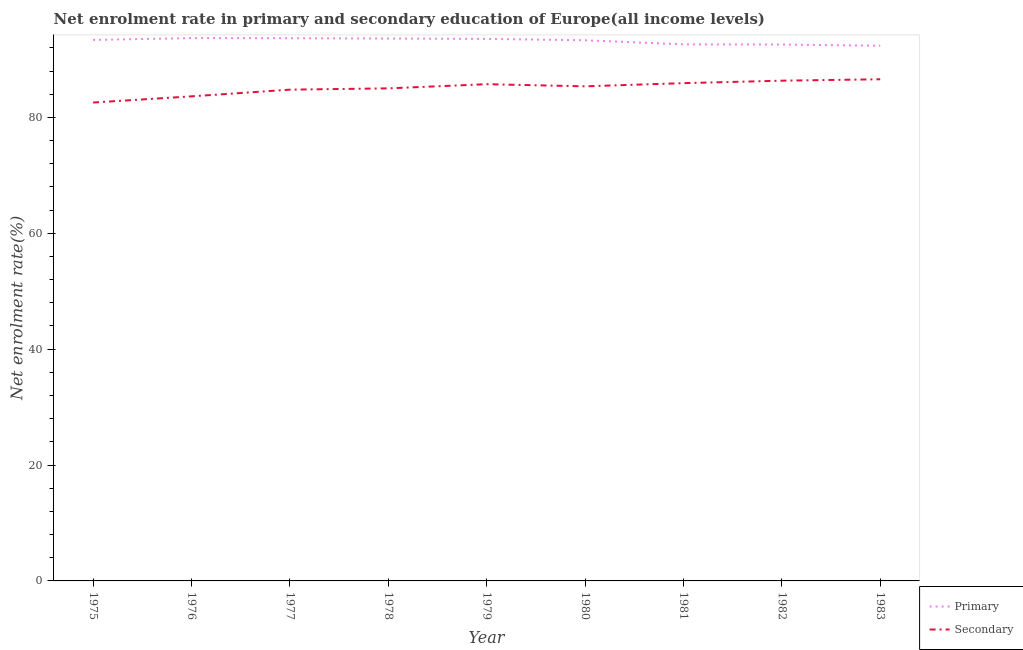Does the line corresponding to enrollment rate in primary education intersect with the line corresponding to enrollment rate in secondary education?
Keep it short and to the point. No. What is the enrollment rate in secondary education in 1980?
Your response must be concise. 85.36. Across all years, what is the maximum enrollment rate in primary education?
Make the answer very short. 93.68. Across all years, what is the minimum enrollment rate in primary education?
Offer a terse response. 92.36. In which year was the enrollment rate in primary education maximum?
Keep it short and to the point. 1976. What is the total enrollment rate in primary education in the graph?
Your response must be concise. 838.69. What is the difference between the enrollment rate in secondary education in 1976 and that in 1982?
Provide a short and direct response. -2.7. What is the difference between the enrollment rate in secondary education in 1976 and the enrollment rate in primary education in 1975?
Make the answer very short. -9.74. What is the average enrollment rate in primary education per year?
Keep it short and to the point. 93.19. In the year 1978, what is the difference between the enrollment rate in secondary education and enrollment rate in primary education?
Make the answer very short. -8.6. In how many years, is the enrollment rate in secondary education greater than 12 %?
Keep it short and to the point. 9. What is the ratio of the enrollment rate in primary education in 1975 to that in 1976?
Give a very brief answer. 1. What is the difference between the highest and the second highest enrollment rate in secondary education?
Provide a short and direct response. 0.25. What is the difference between the highest and the lowest enrollment rate in primary education?
Make the answer very short. 1.32. Is the sum of the enrollment rate in secondary education in 1976 and 1977 greater than the maximum enrollment rate in primary education across all years?
Make the answer very short. Yes. Is the enrollment rate in primary education strictly greater than the enrollment rate in secondary education over the years?
Your answer should be compact. Yes. What is the difference between two consecutive major ticks on the Y-axis?
Provide a succinct answer. 20. Are the values on the major ticks of Y-axis written in scientific E-notation?
Give a very brief answer. No. Does the graph contain any zero values?
Provide a succinct answer. No. How many legend labels are there?
Provide a short and direct response. 2. How are the legend labels stacked?
Offer a very short reply. Vertical. What is the title of the graph?
Provide a succinct answer. Net enrolment rate in primary and secondary education of Europe(all income levels). Does "Highest 10% of population" appear as one of the legend labels in the graph?
Ensure brevity in your answer.  No. What is the label or title of the X-axis?
Your response must be concise. Year. What is the label or title of the Y-axis?
Give a very brief answer. Net enrolment rate(%). What is the Net enrolment rate(%) in Primary in 1975?
Keep it short and to the point. 93.37. What is the Net enrolment rate(%) of Secondary in 1975?
Your answer should be very brief. 82.56. What is the Net enrolment rate(%) of Primary in 1976?
Your answer should be compact. 93.68. What is the Net enrolment rate(%) of Secondary in 1976?
Make the answer very short. 83.63. What is the Net enrolment rate(%) in Primary in 1977?
Your answer should be compact. 93.66. What is the Net enrolment rate(%) in Secondary in 1977?
Make the answer very short. 84.78. What is the Net enrolment rate(%) of Primary in 1978?
Provide a succinct answer. 93.61. What is the Net enrolment rate(%) in Secondary in 1978?
Offer a very short reply. 85.01. What is the Net enrolment rate(%) of Primary in 1979?
Your answer should be very brief. 93.54. What is the Net enrolment rate(%) in Secondary in 1979?
Offer a very short reply. 85.72. What is the Net enrolment rate(%) of Primary in 1980?
Provide a succinct answer. 93.31. What is the Net enrolment rate(%) in Secondary in 1980?
Provide a succinct answer. 85.36. What is the Net enrolment rate(%) of Primary in 1981?
Give a very brief answer. 92.6. What is the Net enrolment rate(%) of Secondary in 1981?
Your answer should be compact. 85.91. What is the Net enrolment rate(%) of Primary in 1982?
Your answer should be compact. 92.57. What is the Net enrolment rate(%) of Secondary in 1982?
Provide a succinct answer. 86.33. What is the Net enrolment rate(%) in Primary in 1983?
Offer a very short reply. 92.36. What is the Net enrolment rate(%) of Secondary in 1983?
Your answer should be compact. 86.58. Across all years, what is the maximum Net enrolment rate(%) of Primary?
Ensure brevity in your answer.  93.68. Across all years, what is the maximum Net enrolment rate(%) in Secondary?
Keep it short and to the point. 86.58. Across all years, what is the minimum Net enrolment rate(%) in Primary?
Keep it short and to the point. 92.36. Across all years, what is the minimum Net enrolment rate(%) of Secondary?
Make the answer very short. 82.56. What is the total Net enrolment rate(%) of Primary in the graph?
Offer a very short reply. 838.69. What is the total Net enrolment rate(%) of Secondary in the graph?
Your response must be concise. 765.88. What is the difference between the Net enrolment rate(%) in Primary in 1975 and that in 1976?
Provide a succinct answer. -0.32. What is the difference between the Net enrolment rate(%) in Secondary in 1975 and that in 1976?
Provide a short and direct response. -1.07. What is the difference between the Net enrolment rate(%) of Primary in 1975 and that in 1977?
Provide a short and direct response. -0.29. What is the difference between the Net enrolment rate(%) in Secondary in 1975 and that in 1977?
Keep it short and to the point. -2.22. What is the difference between the Net enrolment rate(%) in Primary in 1975 and that in 1978?
Give a very brief answer. -0.25. What is the difference between the Net enrolment rate(%) in Secondary in 1975 and that in 1978?
Give a very brief answer. -2.45. What is the difference between the Net enrolment rate(%) in Primary in 1975 and that in 1979?
Your response must be concise. -0.17. What is the difference between the Net enrolment rate(%) in Secondary in 1975 and that in 1979?
Provide a short and direct response. -3.16. What is the difference between the Net enrolment rate(%) in Primary in 1975 and that in 1980?
Provide a short and direct response. 0.06. What is the difference between the Net enrolment rate(%) in Secondary in 1975 and that in 1980?
Provide a short and direct response. -2.8. What is the difference between the Net enrolment rate(%) of Primary in 1975 and that in 1981?
Make the answer very short. 0.77. What is the difference between the Net enrolment rate(%) in Secondary in 1975 and that in 1981?
Provide a short and direct response. -3.35. What is the difference between the Net enrolment rate(%) of Primary in 1975 and that in 1982?
Give a very brief answer. 0.8. What is the difference between the Net enrolment rate(%) of Secondary in 1975 and that in 1982?
Give a very brief answer. -3.77. What is the difference between the Net enrolment rate(%) in Primary in 1975 and that in 1983?
Your response must be concise. 1. What is the difference between the Net enrolment rate(%) in Secondary in 1975 and that in 1983?
Give a very brief answer. -4.02. What is the difference between the Net enrolment rate(%) in Primary in 1976 and that in 1977?
Give a very brief answer. 0.02. What is the difference between the Net enrolment rate(%) of Secondary in 1976 and that in 1977?
Give a very brief answer. -1.15. What is the difference between the Net enrolment rate(%) of Primary in 1976 and that in 1978?
Your answer should be very brief. 0.07. What is the difference between the Net enrolment rate(%) of Secondary in 1976 and that in 1978?
Keep it short and to the point. -1.38. What is the difference between the Net enrolment rate(%) in Primary in 1976 and that in 1979?
Provide a succinct answer. 0.14. What is the difference between the Net enrolment rate(%) of Secondary in 1976 and that in 1979?
Offer a terse response. -2.1. What is the difference between the Net enrolment rate(%) of Primary in 1976 and that in 1980?
Give a very brief answer. 0.37. What is the difference between the Net enrolment rate(%) in Secondary in 1976 and that in 1980?
Provide a succinct answer. -1.73. What is the difference between the Net enrolment rate(%) of Primary in 1976 and that in 1981?
Provide a short and direct response. 1.08. What is the difference between the Net enrolment rate(%) in Secondary in 1976 and that in 1981?
Provide a succinct answer. -2.28. What is the difference between the Net enrolment rate(%) of Primary in 1976 and that in 1982?
Keep it short and to the point. 1.11. What is the difference between the Net enrolment rate(%) of Secondary in 1976 and that in 1982?
Ensure brevity in your answer.  -2.7. What is the difference between the Net enrolment rate(%) in Primary in 1976 and that in 1983?
Offer a very short reply. 1.32. What is the difference between the Net enrolment rate(%) in Secondary in 1976 and that in 1983?
Your answer should be compact. -2.95. What is the difference between the Net enrolment rate(%) of Primary in 1977 and that in 1978?
Offer a terse response. 0.04. What is the difference between the Net enrolment rate(%) in Secondary in 1977 and that in 1978?
Offer a terse response. -0.22. What is the difference between the Net enrolment rate(%) of Primary in 1977 and that in 1979?
Keep it short and to the point. 0.12. What is the difference between the Net enrolment rate(%) of Secondary in 1977 and that in 1979?
Offer a terse response. -0.94. What is the difference between the Net enrolment rate(%) of Primary in 1977 and that in 1980?
Keep it short and to the point. 0.35. What is the difference between the Net enrolment rate(%) of Secondary in 1977 and that in 1980?
Ensure brevity in your answer.  -0.57. What is the difference between the Net enrolment rate(%) in Primary in 1977 and that in 1981?
Provide a succinct answer. 1.06. What is the difference between the Net enrolment rate(%) in Secondary in 1977 and that in 1981?
Your answer should be very brief. -1.12. What is the difference between the Net enrolment rate(%) of Primary in 1977 and that in 1982?
Your answer should be very brief. 1.09. What is the difference between the Net enrolment rate(%) of Secondary in 1977 and that in 1982?
Provide a succinct answer. -1.55. What is the difference between the Net enrolment rate(%) in Primary in 1977 and that in 1983?
Provide a succinct answer. 1.3. What is the difference between the Net enrolment rate(%) in Secondary in 1977 and that in 1983?
Keep it short and to the point. -1.79. What is the difference between the Net enrolment rate(%) of Primary in 1978 and that in 1979?
Offer a terse response. 0.07. What is the difference between the Net enrolment rate(%) of Secondary in 1978 and that in 1979?
Ensure brevity in your answer.  -0.72. What is the difference between the Net enrolment rate(%) of Primary in 1978 and that in 1980?
Give a very brief answer. 0.3. What is the difference between the Net enrolment rate(%) of Secondary in 1978 and that in 1980?
Your answer should be compact. -0.35. What is the difference between the Net enrolment rate(%) of Primary in 1978 and that in 1981?
Offer a very short reply. 1.01. What is the difference between the Net enrolment rate(%) in Secondary in 1978 and that in 1981?
Provide a succinct answer. -0.9. What is the difference between the Net enrolment rate(%) of Primary in 1978 and that in 1982?
Offer a terse response. 1.04. What is the difference between the Net enrolment rate(%) in Secondary in 1978 and that in 1982?
Offer a very short reply. -1.32. What is the difference between the Net enrolment rate(%) of Primary in 1978 and that in 1983?
Your answer should be compact. 1.25. What is the difference between the Net enrolment rate(%) of Secondary in 1978 and that in 1983?
Offer a terse response. -1.57. What is the difference between the Net enrolment rate(%) in Primary in 1979 and that in 1980?
Your answer should be very brief. 0.23. What is the difference between the Net enrolment rate(%) in Secondary in 1979 and that in 1980?
Offer a very short reply. 0.37. What is the difference between the Net enrolment rate(%) of Primary in 1979 and that in 1981?
Offer a very short reply. 0.94. What is the difference between the Net enrolment rate(%) in Secondary in 1979 and that in 1981?
Give a very brief answer. -0.18. What is the difference between the Net enrolment rate(%) in Primary in 1979 and that in 1982?
Offer a terse response. 0.97. What is the difference between the Net enrolment rate(%) in Secondary in 1979 and that in 1982?
Offer a terse response. -0.61. What is the difference between the Net enrolment rate(%) of Primary in 1979 and that in 1983?
Make the answer very short. 1.18. What is the difference between the Net enrolment rate(%) in Secondary in 1979 and that in 1983?
Your answer should be very brief. -0.85. What is the difference between the Net enrolment rate(%) in Primary in 1980 and that in 1981?
Your answer should be compact. 0.71. What is the difference between the Net enrolment rate(%) of Secondary in 1980 and that in 1981?
Offer a very short reply. -0.55. What is the difference between the Net enrolment rate(%) in Primary in 1980 and that in 1982?
Provide a short and direct response. 0.74. What is the difference between the Net enrolment rate(%) of Secondary in 1980 and that in 1982?
Keep it short and to the point. -0.97. What is the difference between the Net enrolment rate(%) of Primary in 1980 and that in 1983?
Keep it short and to the point. 0.95. What is the difference between the Net enrolment rate(%) of Secondary in 1980 and that in 1983?
Give a very brief answer. -1.22. What is the difference between the Net enrolment rate(%) of Primary in 1981 and that in 1982?
Your answer should be very brief. 0.03. What is the difference between the Net enrolment rate(%) in Secondary in 1981 and that in 1982?
Your response must be concise. -0.43. What is the difference between the Net enrolment rate(%) in Primary in 1981 and that in 1983?
Offer a terse response. 0.24. What is the difference between the Net enrolment rate(%) in Secondary in 1981 and that in 1983?
Offer a very short reply. -0.67. What is the difference between the Net enrolment rate(%) in Primary in 1982 and that in 1983?
Provide a succinct answer. 0.21. What is the difference between the Net enrolment rate(%) in Secondary in 1982 and that in 1983?
Give a very brief answer. -0.25. What is the difference between the Net enrolment rate(%) of Primary in 1975 and the Net enrolment rate(%) of Secondary in 1976?
Ensure brevity in your answer.  9.74. What is the difference between the Net enrolment rate(%) of Primary in 1975 and the Net enrolment rate(%) of Secondary in 1977?
Offer a very short reply. 8.58. What is the difference between the Net enrolment rate(%) in Primary in 1975 and the Net enrolment rate(%) in Secondary in 1978?
Your answer should be compact. 8.36. What is the difference between the Net enrolment rate(%) in Primary in 1975 and the Net enrolment rate(%) in Secondary in 1979?
Keep it short and to the point. 7.64. What is the difference between the Net enrolment rate(%) of Primary in 1975 and the Net enrolment rate(%) of Secondary in 1980?
Your answer should be very brief. 8.01. What is the difference between the Net enrolment rate(%) in Primary in 1975 and the Net enrolment rate(%) in Secondary in 1981?
Your answer should be compact. 7.46. What is the difference between the Net enrolment rate(%) in Primary in 1975 and the Net enrolment rate(%) in Secondary in 1982?
Your answer should be very brief. 7.03. What is the difference between the Net enrolment rate(%) of Primary in 1975 and the Net enrolment rate(%) of Secondary in 1983?
Your answer should be very brief. 6.79. What is the difference between the Net enrolment rate(%) in Primary in 1976 and the Net enrolment rate(%) in Secondary in 1977?
Your response must be concise. 8.9. What is the difference between the Net enrolment rate(%) in Primary in 1976 and the Net enrolment rate(%) in Secondary in 1978?
Provide a short and direct response. 8.67. What is the difference between the Net enrolment rate(%) in Primary in 1976 and the Net enrolment rate(%) in Secondary in 1979?
Your answer should be compact. 7.96. What is the difference between the Net enrolment rate(%) of Primary in 1976 and the Net enrolment rate(%) of Secondary in 1980?
Provide a short and direct response. 8.32. What is the difference between the Net enrolment rate(%) in Primary in 1976 and the Net enrolment rate(%) in Secondary in 1981?
Offer a very short reply. 7.78. What is the difference between the Net enrolment rate(%) in Primary in 1976 and the Net enrolment rate(%) in Secondary in 1982?
Your response must be concise. 7.35. What is the difference between the Net enrolment rate(%) of Primary in 1976 and the Net enrolment rate(%) of Secondary in 1983?
Your answer should be very brief. 7.1. What is the difference between the Net enrolment rate(%) in Primary in 1977 and the Net enrolment rate(%) in Secondary in 1978?
Make the answer very short. 8.65. What is the difference between the Net enrolment rate(%) in Primary in 1977 and the Net enrolment rate(%) in Secondary in 1979?
Ensure brevity in your answer.  7.93. What is the difference between the Net enrolment rate(%) of Primary in 1977 and the Net enrolment rate(%) of Secondary in 1980?
Your response must be concise. 8.3. What is the difference between the Net enrolment rate(%) in Primary in 1977 and the Net enrolment rate(%) in Secondary in 1981?
Keep it short and to the point. 7.75. What is the difference between the Net enrolment rate(%) of Primary in 1977 and the Net enrolment rate(%) of Secondary in 1982?
Your answer should be compact. 7.33. What is the difference between the Net enrolment rate(%) of Primary in 1977 and the Net enrolment rate(%) of Secondary in 1983?
Your answer should be very brief. 7.08. What is the difference between the Net enrolment rate(%) in Primary in 1978 and the Net enrolment rate(%) in Secondary in 1979?
Provide a succinct answer. 7.89. What is the difference between the Net enrolment rate(%) in Primary in 1978 and the Net enrolment rate(%) in Secondary in 1980?
Provide a succinct answer. 8.25. What is the difference between the Net enrolment rate(%) of Primary in 1978 and the Net enrolment rate(%) of Secondary in 1981?
Provide a short and direct response. 7.71. What is the difference between the Net enrolment rate(%) of Primary in 1978 and the Net enrolment rate(%) of Secondary in 1982?
Give a very brief answer. 7.28. What is the difference between the Net enrolment rate(%) in Primary in 1978 and the Net enrolment rate(%) in Secondary in 1983?
Provide a short and direct response. 7.03. What is the difference between the Net enrolment rate(%) of Primary in 1979 and the Net enrolment rate(%) of Secondary in 1980?
Offer a terse response. 8.18. What is the difference between the Net enrolment rate(%) of Primary in 1979 and the Net enrolment rate(%) of Secondary in 1981?
Ensure brevity in your answer.  7.63. What is the difference between the Net enrolment rate(%) in Primary in 1979 and the Net enrolment rate(%) in Secondary in 1982?
Your response must be concise. 7.21. What is the difference between the Net enrolment rate(%) in Primary in 1979 and the Net enrolment rate(%) in Secondary in 1983?
Your answer should be very brief. 6.96. What is the difference between the Net enrolment rate(%) of Primary in 1980 and the Net enrolment rate(%) of Secondary in 1981?
Offer a terse response. 7.4. What is the difference between the Net enrolment rate(%) in Primary in 1980 and the Net enrolment rate(%) in Secondary in 1982?
Make the answer very short. 6.98. What is the difference between the Net enrolment rate(%) of Primary in 1980 and the Net enrolment rate(%) of Secondary in 1983?
Provide a succinct answer. 6.73. What is the difference between the Net enrolment rate(%) in Primary in 1981 and the Net enrolment rate(%) in Secondary in 1982?
Make the answer very short. 6.27. What is the difference between the Net enrolment rate(%) of Primary in 1981 and the Net enrolment rate(%) of Secondary in 1983?
Your answer should be very brief. 6.02. What is the difference between the Net enrolment rate(%) in Primary in 1982 and the Net enrolment rate(%) in Secondary in 1983?
Offer a terse response. 5.99. What is the average Net enrolment rate(%) in Primary per year?
Your answer should be very brief. 93.19. What is the average Net enrolment rate(%) in Secondary per year?
Provide a succinct answer. 85.1. In the year 1975, what is the difference between the Net enrolment rate(%) in Primary and Net enrolment rate(%) in Secondary?
Your answer should be very brief. 10.81. In the year 1976, what is the difference between the Net enrolment rate(%) of Primary and Net enrolment rate(%) of Secondary?
Give a very brief answer. 10.05. In the year 1977, what is the difference between the Net enrolment rate(%) in Primary and Net enrolment rate(%) in Secondary?
Provide a short and direct response. 8.87. In the year 1978, what is the difference between the Net enrolment rate(%) in Primary and Net enrolment rate(%) in Secondary?
Keep it short and to the point. 8.6. In the year 1979, what is the difference between the Net enrolment rate(%) in Primary and Net enrolment rate(%) in Secondary?
Your answer should be very brief. 7.81. In the year 1980, what is the difference between the Net enrolment rate(%) in Primary and Net enrolment rate(%) in Secondary?
Give a very brief answer. 7.95. In the year 1981, what is the difference between the Net enrolment rate(%) of Primary and Net enrolment rate(%) of Secondary?
Offer a very short reply. 6.69. In the year 1982, what is the difference between the Net enrolment rate(%) of Primary and Net enrolment rate(%) of Secondary?
Provide a short and direct response. 6.24. In the year 1983, what is the difference between the Net enrolment rate(%) in Primary and Net enrolment rate(%) in Secondary?
Your response must be concise. 5.78. What is the ratio of the Net enrolment rate(%) in Primary in 1975 to that in 1976?
Provide a short and direct response. 1. What is the ratio of the Net enrolment rate(%) in Secondary in 1975 to that in 1976?
Make the answer very short. 0.99. What is the ratio of the Net enrolment rate(%) in Primary in 1975 to that in 1977?
Your answer should be compact. 1. What is the ratio of the Net enrolment rate(%) in Secondary in 1975 to that in 1977?
Keep it short and to the point. 0.97. What is the ratio of the Net enrolment rate(%) of Primary in 1975 to that in 1978?
Your answer should be compact. 1. What is the ratio of the Net enrolment rate(%) in Secondary in 1975 to that in 1978?
Offer a very short reply. 0.97. What is the ratio of the Net enrolment rate(%) of Secondary in 1975 to that in 1979?
Make the answer very short. 0.96. What is the ratio of the Net enrolment rate(%) in Secondary in 1975 to that in 1980?
Provide a short and direct response. 0.97. What is the ratio of the Net enrolment rate(%) in Primary in 1975 to that in 1981?
Keep it short and to the point. 1.01. What is the ratio of the Net enrolment rate(%) of Secondary in 1975 to that in 1981?
Offer a very short reply. 0.96. What is the ratio of the Net enrolment rate(%) of Primary in 1975 to that in 1982?
Keep it short and to the point. 1.01. What is the ratio of the Net enrolment rate(%) of Secondary in 1975 to that in 1982?
Give a very brief answer. 0.96. What is the ratio of the Net enrolment rate(%) of Primary in 1975 to that in 1983?
Give a very brief answer. 1.01. What is the ratio of the Net enrolment rate(%) in Secondary in 1975 to that in 1983?
Make the answer very short. 0.95. What is the ratio of the Net enrolment rate(%) of Primary in 1976 to that in 1977?
Your response must be concise. 1. What is the ratio of the Net enrolment rate(%) of Secondary in 1976 to that in 1977?
Offer a terse response. 0.99. What is the ratio of the Net enrolment rate(%) in Secondary in 1976 to that in 1978?
Provide a succinct answer. 0.98. What is the ratio of the Net enrolment rate(%) in Primary in 1976 to that in 1979?
Keep it short and to the point. 1. What is the ratio of the Net enrolment rate(%) in Secondary in 1976 to that in 1979?
Your answer should be compact. 0.98. What is the ratio of the Net enrolment rate(%) of Primary in 1976 to that in 1980?
Offer a terse response. 1. What is the ratio of the Net enrolment rate(%) of Secondary in 1976 to that in 1980?
Offer a very short reply. 0.98. What is the ratio of the Net enrolment rate(%) in Primary in 1976 to that in 1981?
Your response must be concise. 1.01. What is the ratio of the Net enrolment rate(%) in Secondary in 1976 to that in 1981?
Your answer should be compact. 0.97. What is the ratio of the Net enrolment rate(%) in Primary in 1976 to that in 1982?
Your response must be concise. 1.01. What is the ratio of the Net enrolment rate(%) in Secondary in 1976 to that in 1982?
Offer a very short reply. 0.97. What is the ratio of the Net enrolment rate(%) in Primary in 1976 to that in 1983?
Provide a succinct answer. 1.01. What is the ratio of the Net enrolment rate(%) of Secondary in 1976 to that in 1983?
Make the answer very short. 0.97. What is the ratio of the Net enrolment rate(%) of Secondary in 1977 to that in 1978?
Keep it short and to the point. 1. What is the ratio of the Net enrolment rate(%) of Secondary in 1977 to that in 1979?
Keep it short and to the point. 0.99. What is the ratio of the Net enrolment rate(%) of Primary in 1977 to that in 1980?
Make the answer very short. 1. What is the ratio of the Net enrolment rate(%) of Secondary in 1977 to that in 1980?
Make the answer very short. 0.99. What is the ratio of the Net enrolment rate(%) of Primary in 1977 to that in 1981?
Provide a short and direct response. 1.01. What is the ratio of the Net enrolment rate(%) of Secondary in 1977 to that in 1981?
Give a very brief answer. 0.99. What is the ratio of the Net enrolment rate(%) of Primary in 1977 to that in 1982?
Offer a terse response. 1.01. What is the ratio of the Net enrolment rate(%) in Secondary in 1977 to that in 1982?
Make the answer very short. 0.98. What is the ratio of the Net enrolment rate(%) of Primary in 1977 to that in 1983?
Offer a terse response. 1.01. What is the ratio of the Net enrolment rate(%) of Secondary in 1977 to that in 1983?
Your response must be concise. 0.98. What is the ratio of the Net enrolment rate(%) in Primary in 1978 to that in 1979?
Make the answer very short. 1. What is the ratio of the Net enrolment rate(%) of Primary in 1978 to that in 1980?
Offer a terse response. 1. What is the ratio of the Net enrolment rate(%) of Secondary in 1978 to that in 1980?
Keep it short and to the point. 1. What is the ratio of the Net enrolment rate(%) in Primary in 1978 to that in 1981?
Your response must be concise. 1.01. What is the ratio of the Net enrolment rate(%) in Secondary in 1978 to that in 1981?
Your response must be concise. 0.99. What is the ratio of the Net enrolment rate(%) of Primary in 1978 to that in 1982?
Make the answer very short. 1.01. What is the ratio of the Net enrolment rate(%) of Secondary in 1978 to that in 1982?
Provide a succinct answer. 0.98. What is the ratio of the Net enrolment rate(%) in Primary in 1978 to that in 1983?
Provide a succinct answer. 1.01. What is the ratio of the Net enrolment rate(%) of Secondary in 1978 to that in 1983?
Offer a terse response. 0.98. What is the ratio of the Net enrolment rate(%) in Secondary in 1979 to that in 1980?
Your answer should be very brief. 1. What is the ratio of the Net enrolment rate(%) of Primary in 1979 to that in 1982?
Keep it short and to the point. 1.01. What is the ratio of the Net enrolment rate(%) in Primary in 1979 to that in 1983?
Provide a succinct answer. 1.01. What is the ratio of the Net enrolment rate(%) in Secondary in 1979 to that in 1983?
Your response must be concise. 0.99. What is the ratio of the Net enrolment rate(%) of Primary in 1980 to that in 1981?
Offer a very short reply. 1.01. What is the ratio of the Net enrolment rate(%) of Secondary in 1980 to that in 1981?
Provide a short and direct response. 0.99. What is the ratio of the Net enrolment rate(%) of Secondary in 1980 to that in 1982?
Your answer should be compact. 0.99. What is the ratio of the Net enrolment rate(%) of Primary in 1980 to that in 1983?
Your answer should be compact. 1.01. What is the ratio of the Net enrolment rate(%) in Secondary in 1980 to that in 1983?
Make the answer very short. 0.99. What is the ratio of the Net enrolment rate(%) of Secondary in 1981 to that in 1982?
Your answer should be very brief. 1. What is the ratio of the Net enrolment rate(%) in Primary in 1981 to that in 1983?
Provide a short and direct response. 1. What is the ratio of the Net enrolment rate(%) of Secondary in 1981 to that in 1983?
Your answer should be very brief. 0.99. What is the ratio of the Net enrolment rate(%) in Secondary in 1982 to that in 1983?
Make the answer very short. 1. What is the difference between the highest and the second highest Net enrolment rate(%) in Primary?
Provide a succinct answer. 0.02. What is the difference between the highest and the second highest Net enrolment rate(%) in Secondary?
Make the answer very short. 0.25. What is the difference between the highest and the lowest Net enrolment rate(%) in Primary?
Give a very brief answer. 1.32. What is the difference between the highest and the lowest Net enrolment rate(%) in Secondary?
Ensure brevity in your answer.  4.02. 